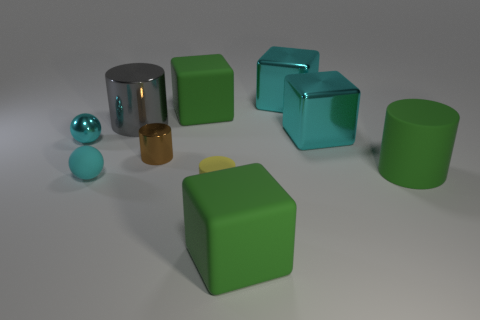The big green object to the left of the green matte cube in front of the small cyan metallic object is made of what material?
Give a very brief answer. Rubber. How many other objects are there of the same shape as the brown metal thing?
Make the answer very short. 3. There is a large green thing that is on the left side of the yellow rubber cylinder; is its shape the same as the green object that is in front of the big green matte cylinder?
Offer a very short reply. Yes. Is there any other thing that has the same material as the small yellow thing?
Ensure brevity in your answer.  Yes. What is the material of the brown cylinder?
Your answer should be compact. Metal. What is the tiny cylinder behind the tiny yellow matte cylinder made of?
Offer a very short reply. Metal. Are there any other things that are the same color as the tiny matte cylinder?
Provide a short and direct response. No. What size is the cyan sphere that is made of the same material as the brown cylinder?
Your answer should be compact. Small. What number of large things are either yellow cylinders or green cylinders?
Your response must be concise. 1. There is a metal object that is in front of the small cyan metal object that is to the left of the tiny cyan rubber thing in front of the large green cylinder; how big is it?
Give a very brief answer. Small. 